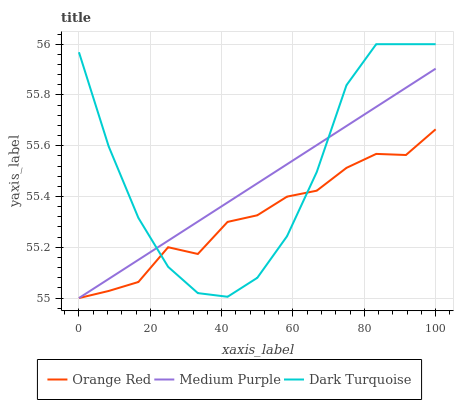Does Orange Red have the minimum area under the curve?
Answer yes or no. Yes. Does Dark Turquoise have the maximum area under the curve?
Answer yes or no. Yes. Does Dark Turquoise have the minimum area under the curve?
Answer yes or no. No. Does Orange Red have the maximum area under the curve?
Answer yes or no. No. Is Medium Purple the smoothest?
Answer yes or no. Yes. Is Dark Turquoise the roughest?
Answer yes or no. Yes. Is Orange Red the smoothest?
Answer yes or no. No. Is Orange Red the roughest?
Answer yes or no. No. Does Medium Purple have the lowest value?
Answer yes or no. Yes. Does Dark Turquoise have the lowest value?
Answer yes or no. No. Does Dark Turquoise have the highest value?
Answer yes or no. Yes. Does Orange Red have the highest value?
Answer yes or no. No. Does Orange Red intersect Dark Turquoise?
Answer yes or no. Yes. Is Orange Red less than Dark Turquoise?
Answer yes or no. No. Is Orange Red greater than Dark Turquoise?
Answer yes or no. No. 